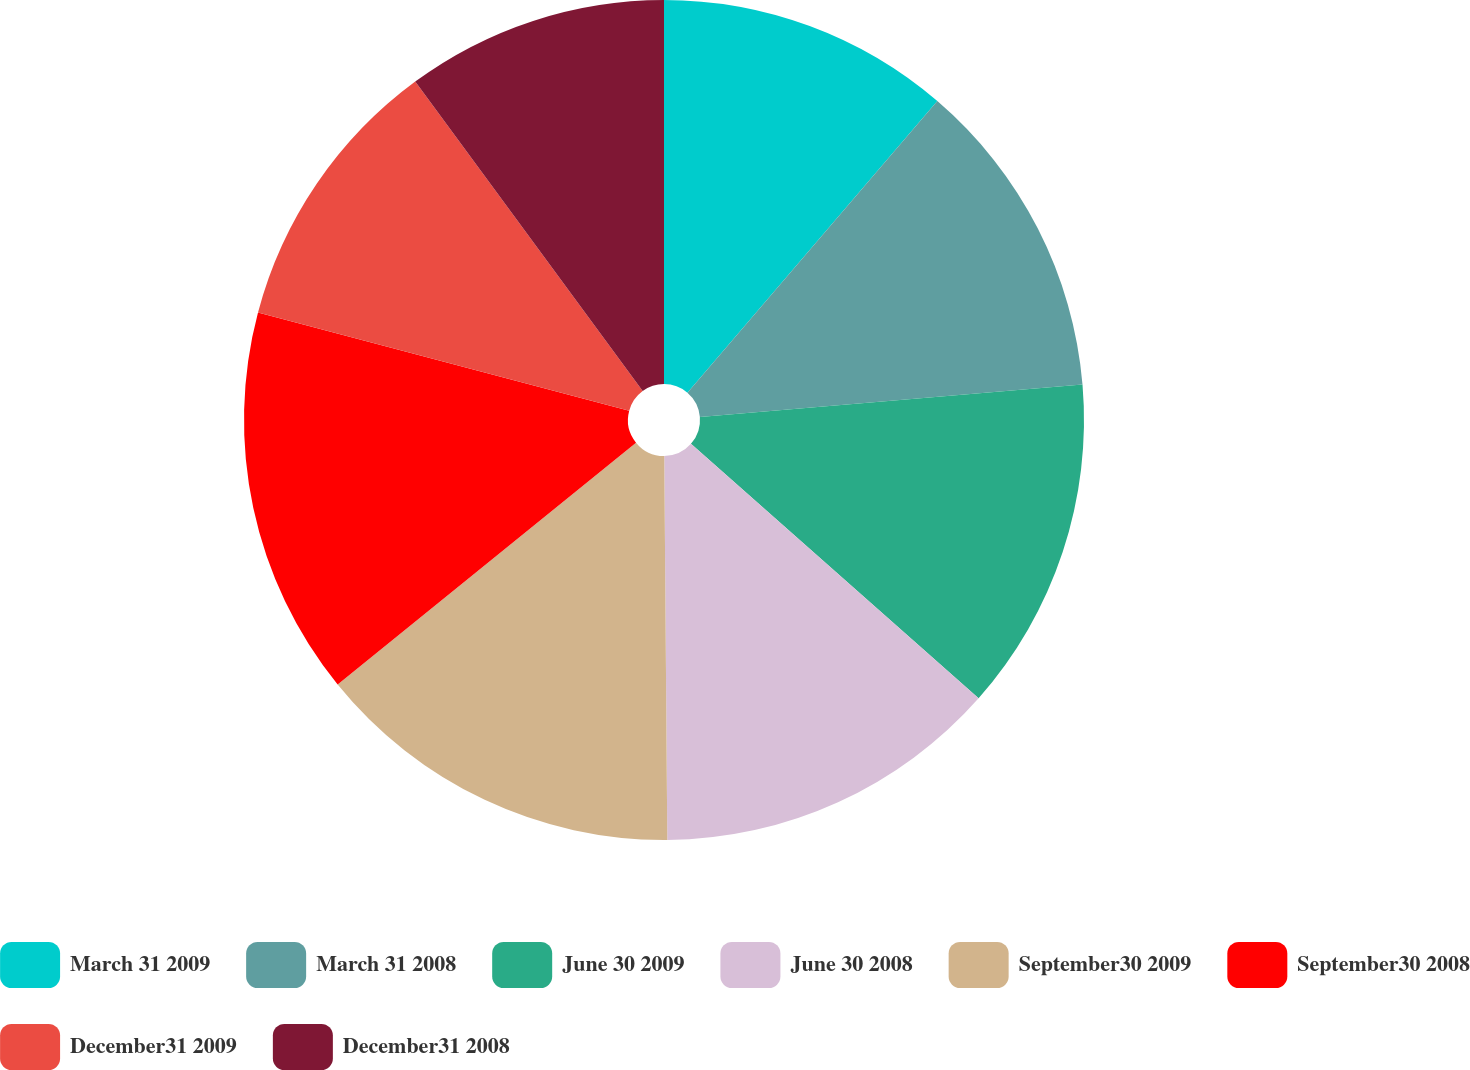Convert chart. <chart><loc_0><loc_0><loc_500><loc_500><pie_chart><fcel>March 31 2009<fcel>March 31 2008<fcel>June 30 2009<fcel>June 30 2008<fcel>September30 2009<fcel>September30 2008<fcel>December31 2009<fcel>December31 2008<nl><fcel>11.28%<fcel>12.38%<fcel>12.87%<fcel>13.35%<fcel>14.29%<fcel>14.96%<fcel>10.79%<fcel>10.09%<nl></chart> 